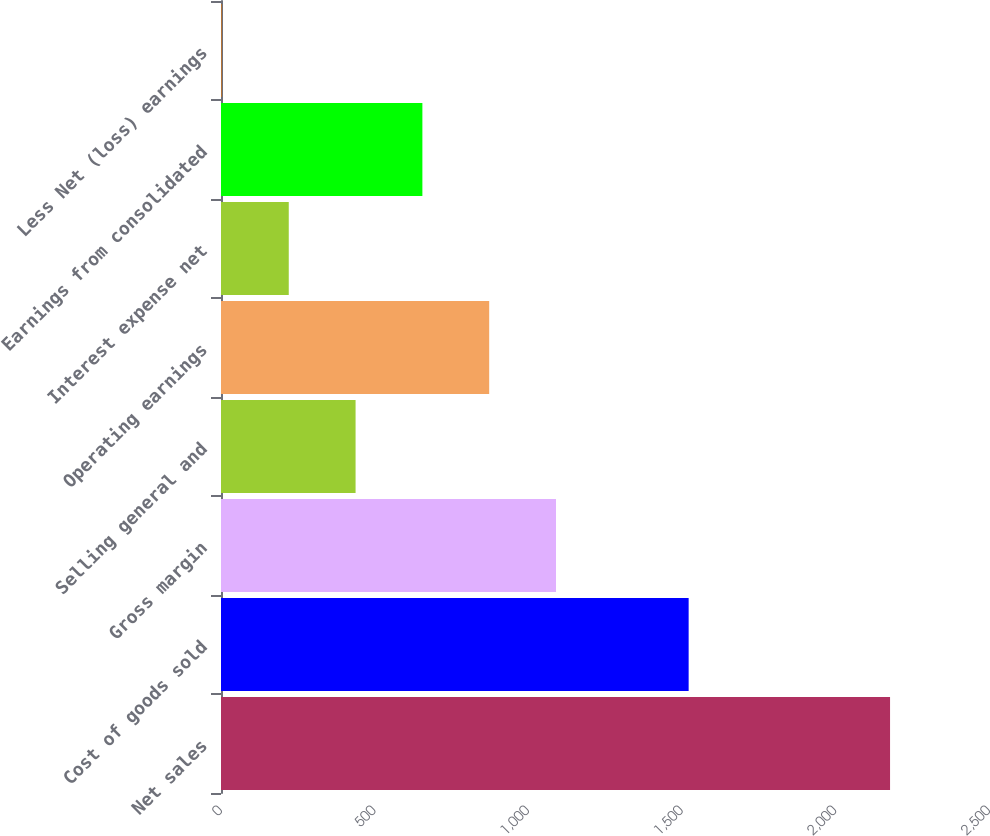Convert chart to OTSL. <chart><loc_0><loc_0><loc_500><loc_500><bar_chart><fcel>Net sales<fcel>Cost of goods sold<fcel>Gross margin<fcel>Selling general and<fcel>Operating earnings<fcel>Interest expense net<fcel>Earnings from consolidated<fcel>Less Net (loss) earnings<nl><fcel>2177.9<fcel>1522.3<fcel>1090.5<fcel>438.06<fcel>873.02<fcel>220.58<fcel>655.54<fcel>3.1<nl></chart> 